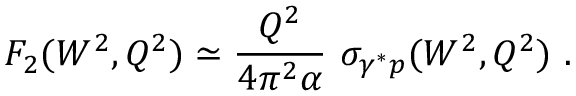Convert formula to latex. <formula><loc_0><loc_0><loc_500><loc_500>F _ { 2 } ( W ^ { 2 } , Q ^ { 2 } ) \simeq \frac { Q ^ { 2 } } { 4 \pi ^ { 2 } \alpha } \sigma _ { \gamma ^ { * } p } ( W ^ { 2 } , Q ^ { 2 } ) .</formula> 